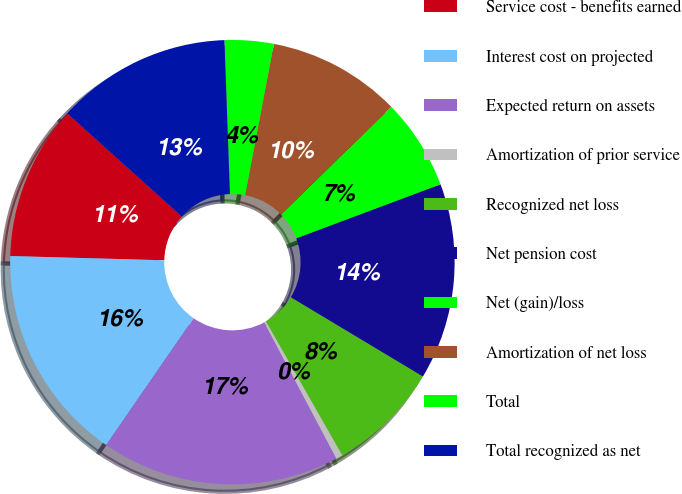Convert chart to OTSL. <chart><loc_0><loc_0><loc_500><loc_500><pie_chart><fcel>Service cost - benefits earned<fcel>Interest cost on projected<fcel>Expected return on assets<fcel>Amortization of prior service<fcel>Recognized net loss<fcel>Net pension cost<fcel>Net (gain)/loss<fcel>Amortization of net loss<fcel>Total<fcel>Total recognized as net<nl><fcel>11.23%<fcel>15.83%<fcel>17.36%<fcel>0.49%<fcel>8.16%<fcel>14.3%<fcel>6.62%<fcel>9.69%<fcel>3.56%<fcel>12.76%<nl></chart> 